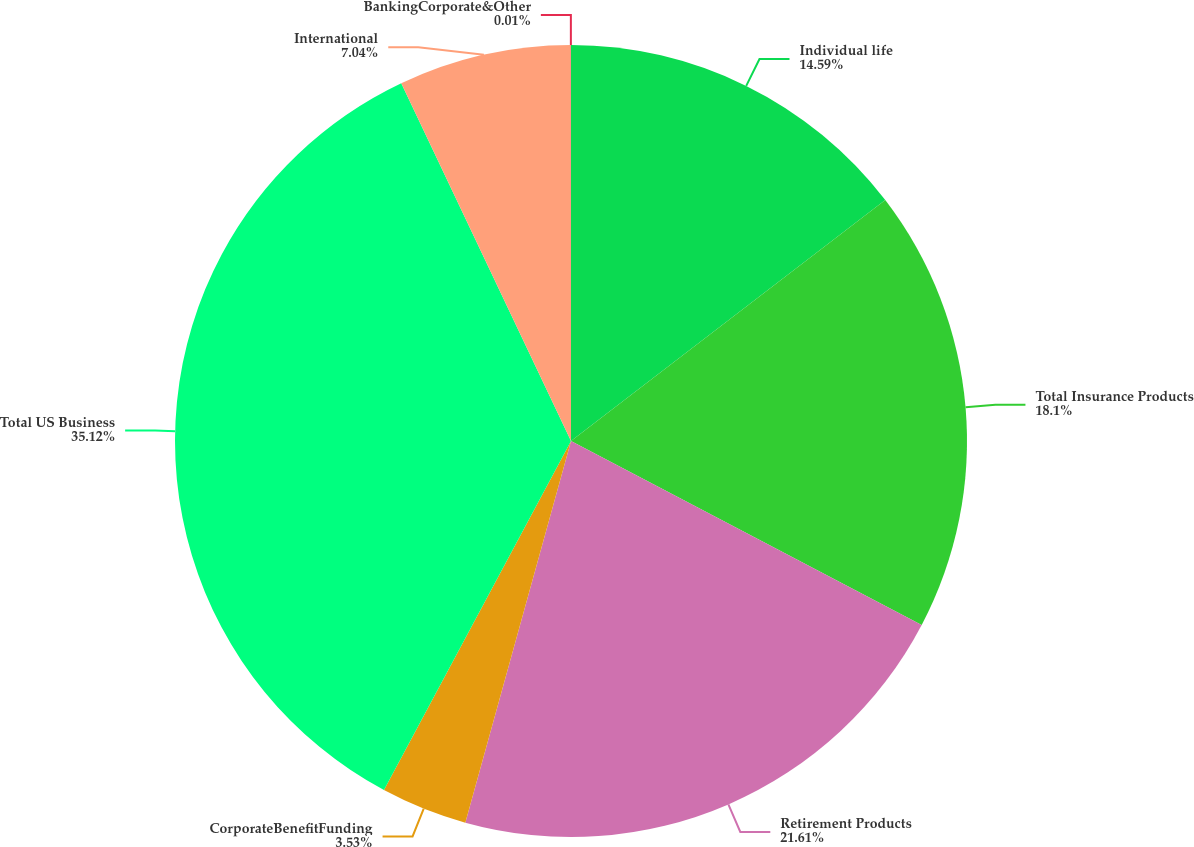Convert chart to OTSL. <chart><loc_0><loc_0><loc_500><loc_500><pie_chart><fcel>Individual life<fcel>Total Insurance Products<fcel>Retirement Products<fcel>CorporateBenefitFunding<fcel>Total US Business<fcel>International<fcel>BankingCorporate&Other<nl><fcel>14.59%<fcel>18.1%<fcel>21.61%<fcel>3.53%<fcel>35.12%<fcel>7.04%<fcel>0.01%<nl></chart> 